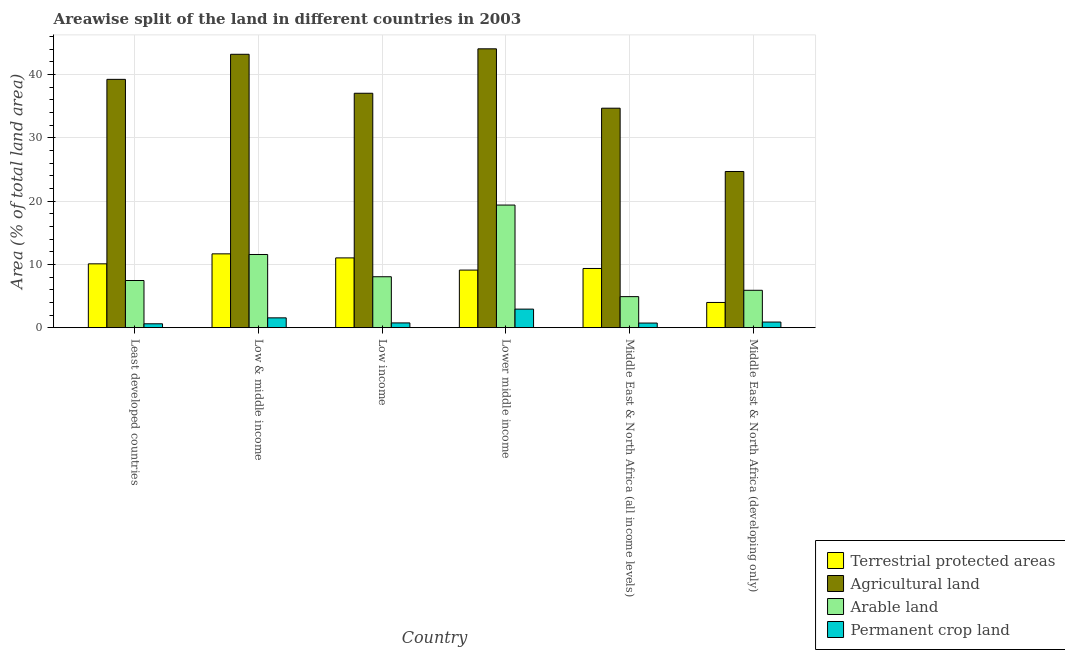How many bars are there on the 4th tick from the left?
Ensure brevity in your answer.  4. How many bars are there on the 1st tick from the right?
Make the answer very short. 4. What is the label of the 5th group of bars from the left?
Keep it short and to the point. Middle East & North Africa (all income levels). What is the percentage of area under agricultural land in Low income?
Provide a short and direct response. 37.05. Across all countries, what is the maximum percentage of land under terrestrial protection?
Offer a very short reply. 11.67. Across all countries, what is the minimum percentage of area under permanent crop land?
Ensure brevity in your answer.  0.61. In which country was the percentage of area under arable land maximum?
Your answer should be very brief. Lower middle income. In which country was the percentage of land under terrestrial protection minimum?
Your response must be concise. Middle East & North Africa (developing only). What is the total percentage of area under agricultural land in the graph?
Offer a very short reply. 222.98. What is the difference between the percentage of area under permanent crop land in Low & middle income and that in Lower middle income?
Offer a very short reply. -1.38. What is the difference between the percentage of area under arable land in Low income and the percentage of area under permanent crop land in Least developed countries?
Provide a succinct answer. 7.44. What is the average percentage of area under permanent crop land per country?
Your answer should be very brief. 1.24. What is the difference between the percentage of area under permanent crop land and percentage of land under terrestrial protection in Low & middle income?
Your response must be concise. -10.12. In how many countries, is the percentage of area under arable land greater than 14 %?
Provide a succinct answer. 1. What is the ratio of the percentage of area under arable land in Lower middle income to that in Middle East & North Africa (all income levels)?
Offer a terse response. 3.95. Is the percentage of area under arable land in Low income less than that in Lower middle income?
Your response must be concise. Yes. Is the difference between the percentage of area under arable land in Least developed countries and Lower middle income greater than the difference between the percentage of area under agricultural land in Least developed countries and Lower middle income?
Provide a short and direct response. No. What is the difference between the highest and the second highest percentage of land under terrestrial protection?
Your response must be concise. 0.64. What is the difference between the highest and the lowest percentage of area under permanent crop land?
Provide a succinct answer. 2.32. What does the 2nd bar from the left in Lower middle income represents?
Your answer should be compact. Agricultural land. What does the 4th bar from the right in Low income represents?
Your answer should be compact. Terrestrial protected areas. Are all the bars in the graph horizontal?
Your response must be concise. No. What is the difference between two consecutive major ticks on the Y-axis?
Ensure brevity in your answer.  10. How many legend labels are there?
Keep it short and to the point. 4. What is the title of the graph?
Keep it short and to the point. Areawise split of the land in different countries in 2003. What is the label or title of the X-axis?
Make the answer very short. Country. What is the label or title of the Y-axis?
Your response must be concise. Area (% of total land area). What is the Area (% of total land area) in Terrestrial protected areas in Least developed countries?
Keep it short and to the point. 10.09. What is the Area (% of total land area) of Agricultural land in Least developed countries?
Offer a very short reply. 39.25. What is the Area (% of total land area) of Arable land in Least developed countries?
Give a very brief answer. 7.45. What is the Area (% of total land area) of Permanent crop land in Least developed countries?
Make the answer very short. 0.61. What is the Area (% of total land area) of Terrestrial protected areas in Low & middle income?
Ensure brevity in your answer.  11.67. What is the Area (% of total land area) of Agricultural land in Low & middle income?
Keep it short and to the point. 43.21. What is the Area (% of total land area) of Arable land in Low & middle income?
Provide a short and direct response. 11.57. What is the Area (% of total land area) in Permanent crop land in Low & middle income?
Your answer should be very brief. 1.55. What is the Area (% of total land area) in Terrestrial protected areas in Low income?
Your answer should be compact. 11.03. What is the Area (% of total land area) of Agricultural land in Low income?
Provide a succinct answer. 37.05. What is the Area (% of total land area) of Arable land in Low income?
Provide a short and direct response. 8.05. What is the Area (% of total land area) in Permanent crop land in Low income?
Offer a very short reply. 0.75. What is the Area (% of total land area) in Terrestrial protected areas in Lower middle income?
Give a very brief answer. 9.1. What is the Area (% of total land area) of Agricultural land in Lower middle income?
Provide a succinct answer. 44.08. What is the Area (% of total land area) in Arable land in Lower middle income?
Provide a succinct answer. 19.38. What is the Area (% of total land area) of Permanent crop land in Lower middle income?
Ensure brevity in your answer.  2.93. What is the Area (% of total land area) of Terrestrial protected areas in Middle East & North Africa (all income levels)?
Your answer should be very brief. 9.36. What is the Area (% of total land area) in Agricultural land in Middle East & North Africa (all income levels)?
Your answer should be compact. 34.69. What is the Area (% of total land area) of Arable land in Middle East & North Africa (all income levels)?
Offer a terse response. 4.9. What is the Area (% of total land area) in Permanent crop land in Middle East & North Africa (all income levels)?
Your response must be concise. 0.73. What is the Area (% of total land area) of Terrestrial protected areas in Middle East & North Africa (developing only)?
Offer a very short reply. 3.98. What is the Area (% of total land area) in Agricultural land in Middle East & North Africa (developing only)?
Keep it short and to the point. 24.69. What is the Area (% of total land area) of Arable land in Middle East & North Africa (developing only)?
Your answer should be compact. 5.91. What is the Area (% of total land area) in Permanent crop land in Middle East & North Africa (developing only)?
Make the answer very short. 0.89. Across all countries, what is the maximum Area (% of total land area) in Terrestrial protected areas?
Your answer should be very brief. 11.67. Across all countries, what is the maximum Area (% of total land area) in Agricultural land?
Your answer should be compact. 44.08. Across all countries, what is the maximum Area (% of total land area) of Arable land?
Give a very brief answer. 19.38. Across all countries, what is the maximum Area (% of total land area) in Permanent crop land?
Give a very brief answer. 2.93. Across all countries, what is the minimum Area (% of total land area) of Terrestrial protected areas?
Your response must be concise. 3.98. Across all countries, what is the minimum Area (% of total land area) of Agricultural land?
Offer a terse response. 24.69. Across all countries, what is the minimum Area (% of total land area) of Arable land?
Your response must be concise. 4.9. Across all countries, what is the minimum Area (% of total land area) of Permanent crop land?
Give a very brief answer. 0.61. What is the total Area (% of total land area) in Terrestrial protected areas in the graph?
Your answer should be compact. 55.23. What is the total Area (% of total land area) in Agricultural land in the graph?
Your answer should be very brief. 222.98. What is the total Area (% of total land area) in Arable land in the graph?
Keep it short and to the point. 57.26. What is the total Area (% of total land area) of Permanent crop land in the graph?
Offer a very short reply. 7.46. What is the difference between the Area (% of total land area) of Terrestrial protected areas in Least developed countries and that in Low & middle income?
Ensure brevity in your answer.  -1.58. What is the difference between the Area (% of total land area) in Agricultural land in Least developed countries and that in Low & middle income?
Make the answer very short. -3.96. What is the difference between the Area (% of total land area) of Arable land in Least developed countries and that in Low & middle income?
Make the answer very short. -4.11. What is the difference between the Area (% of total land area) in Permanent crop land in Least developed countries and that in Low & middle income?
Provide a short and direct response. -0.94. What is the difference between the Area (% of total land area) of Terrestrial protected areas in Least developed countries and that in Low income?
Offer a terse response. -0.94. What is the difference between the Area (% of total land area) in Agricultural land in Least developed countries and that in Low income?
Your response must be concise. 2.2. What is the difference between the Area (% of total land area) in Arable land in Least developed countries and that in Low income?
Give a very brief answer. -0.6. What is the difference between the Area (% of total land area) of Permanent crop land in Least developed countries and that in Low income?
Your response must be concise. -0.14. What is the difference between the Area (% of total land area) in Terrestrial protected areas in Least developed countries and that in Lower middle income?
Your answer should be very brief. 0.99. What is the difference between the Area (% of total land area) of Agricultural land in Least developed countries and that in Lower middle income?
Offer a very short reply. -4.83. What is the difference between the Area (% of total land area) of Arable land in Least developed countries and that in Lower middle income?
Your answer should be compact. -11.93. What is the difference between the Area (% of total land area) of Permanent crop land in Least developed countries and that in Lower middle income?
Make the answer very short. -2.32. What is the difference between the Area (% of total land area) in Terrestrial protected areas in Least developed countries and that in Middle East & North Africa (all income levels)?
Offer a terse response. 0.73. What is the difference between the Area (% of total land area) of Agricultural land in Least developed countries and that in Middle East & North Africa (all income levels)?
Make the answer very short. 4.56. What is the difference between the Area (% of total land area) of Arable land in Least developed countries and that in Middle East & North Africa (all income levels)?
Offer a terse response. 2.55. What is the difference between the Area (% of total land area) in Permanent crop land in Least developed countries and that in Middle East & North Africa (all income levels)?
Give a very brief answer. -0.12. What is the difference between the Area (% of total land area) of Terrestrial protected areas in Least developed countries and that in Middle East & North Africa (developing only)?
Offer a very short reply. 6.11. What is the difference between the Area (% of total land area) of Agricultural land in Least developed countries and that in Middle East & North Africa (developing only)?
Keep it short and to the point. 14.57. What is the difference between the Area (% of total land area) in Arable land in Least developed countries and that in Middle East & North Africa (developing only)?
Your answer should be compact. 1.55. What is the difference between the Area (% of total land area) of Permanent crop land in Least developed countries and that in Middle East & North Africa (developing only)?
Offer a terse response. -0.27. What is the difference between the Area (% of total land area) of Terrestrial protected areas in Low & middle income and that in Low income?
Keep it short and to the point. 0.64. What is the difference between the Area (% of total land area) of Agricultural land in Low & middle income and that in Low income?
Your answer should be very brief. 6.16. What is the difference between the Area (% of total land area) in Arable land in Low & middle income and that in Low income?
Offer a terse response. 3.52. What is the difference between the Area (% of total land area) of Permanent crop land in Low & middle income and that in Low income?
Your answer should be very brief. 0.8. What is the difference between the Area (% of total land area) of Terrestrial protected areas in Low & middle income and that in Lower middle income?
Your response must be concise. 2.57. What is the difference between the Area (% of total land area) in Agricultural land in Low & middle income and that in Lower middle income?
Your answer should be compact. -0.87. What is the difference between the Area (% of total land area) of Arable land in Low & middle income and that in Lower middle income?
Offer a terse response. -7.82. What is the difference between the Area (% of total land area) in Permanent crop land in Low & middle income and that in Lower middle income?
Offer a terse response. -1.38. What is the difference between the Area (% of total land area) in Terrestrial protected areas in Low & middle income and that in Middle East & North Africa (all income levels)?
Ensure brevity in your answer.  2.31. What is the difference between the Area (% of total land area) in Agricultural land in Low & middle income and that in Middle East & North Africa (all income levels)?
Provide a short and direct response. 8.52. What is the difference between the Area (% of total land area) of Arable land in Low & middle income and that in Middle East & North Africa (all income levels)?
Offer a terse response. 6.66. What is the difference between the Area (% of total land area) of Permanent crop land in Low & middle income and that in Middle East & North Africa (all income levels)?
Provide a succinct answer. 0.82. What is the difference between the Area (% of total land area) of Terrestrial protected areas in Low & middle income and that in Middle East & North Africa (developing only)?
Your answer should be compact. 7.69. What is the difference between the Area (% of total land area) of Agricultural land in Low & middle income and that in Middle East & North Africa (developing only)?
Keep it short and to the point. 18.53. What is the difference between the Area (% of total land area) in Arable land in Low & middle income and that in Middle East & North Africa (developing only)?
Give a very brief answer. 5.66. What is the difference between the Area (% of total land area) in Permanent crop land in Low & middle income and that in Middle East & North Africa (developing only)?
Your response must be concise. 0.66. What is the difference between the Area (% of total land area) of Terrestrial protected areas in Low income and that in Lower middle income?
Offer a terse response. 1.93. What is the difference between the Area (% of total land area) of Agricultural land in Low income and that in Lower middle income?
Offer a very short reply. -7.03. What is the difference between the Area (% of total land area) of Arable land in Low income and that in Lower middle income?
Offer a very short reply. -11.33. What is the difference between the Area (% of total land area) in Permanent crop land in Low income and that in Lower middle income?
Ensure brevity in your answer.  -2.18. What is the difference between the Area (% of total land area) of Terrestrial protected areas in Low income and that in Middle East & North Africa (all income levels)?
Keep it short and to the point. 1.67. What is the difference between the Area (% of total land area) of Agricultural land in Low income and that in Middle East & North Africa (all income levels)?
Your answer should be compact. 2.36. What is the difference between the Area (% of total land area) of Arable land in Low income and that in Middle East & North Africa (all income levels)?
Provide a succinct answer. 3.14. What is the difference between the Area (% of total land area) of Permanent crop land in Low income and that in Middle East & North Africa (all income levels)?
Give a very brief answer. 0.02. What is the difference between the Area (% of total land area) of Terrestrial protected areas in Low income and that in Middle East & North Africa (developing only)?
Provide a succinct answer. 7.04. What is the difference between the Area (% of total land area) in Agricultural land in Low income and that in Middle East & North Africa (developing only)?
Keep it short and to the point. 12.37. What is the difference between the Area (% of total land area) in Arable land in Low income and that in Middle East & North Africa (developing only)?
Ensure brevity in your answer.  2.14. What is the difference between the Area (% of total land area) of Permanent crop land in Low income and that in Middle East & North Africa (developing only)?
Your answer should be compact. -0.14. What is the difference between the Area (% of total land area) in Terrestrial protected areas in Lower middle income and that in Middle East & North Africa (all income levels)?
Provide a succinct answer. -0.25. What is the difference between the Area (% of total land area) in Agricultural land in Lower middle income and that in Middle East & North Africa (all income levels)?
Your answer should be very brief. 9.39. What is the difference between the Area (% of total land area) in Arable land in Lower middle income and that in Middle East & North Africa (all income levels)?
Ensure brevity in your answer.  14.48. What is the difference between the Area (% of total land area) in Permanent crop land in Lower middle income and that in Middle East & North Africa (all income levels)?
Your answer should be compact. 2.2. What is the difference between the Area (% of total land area) of Terrestrial protected areas in Lower middle income and that in Middle East & North Africa (developing only)?
Make the answer very short. 5.12. What is the difference between the Area (% of total land area) in Agricultural land in Lower middle income and that in Middle East & North Africa (developing only)?
Offer a terse response. 19.39. What is the difference between the Area (% of total land area) of Arable land in Lower middle income and that in Middle East & North Africa (developing only)?
Ensure brevity in your answer.  13.47. What is the difference between the Area (% of total land area) in Permanent crop land in Lower middle income and that in Middle East & North Africa (developing only)?
Offer a very short reply. 2.05. What is the difference between the Area (% of total land area) of Terrestrial protected areas in Middle East & North Africa (all income levels) and that in Middle East & North Africa (developing only)?
Make the answer very short. 5.37. What is the difference between the Area (% of total land area) of Agricultural land in Middle East & North Africa (all income levels) and that in Middle East & North Africa (developing only)?
Your response must be concise. 10.01. What is the difference between the Area (% of total land area) of Arable land in Middle East & North Africa (all income levels) and that in Middle East & North Africa (developing only)?
Offer a very short reply. -1. What is the difference between the Area (% of total land area) in Permanent crop land in Middle East & North Africa (all income levels) and that in Middle East & North Africa (developing only)?
Your answer should be very brief. -0.16. What is the difference between the Area (% of total land area) of Terrestrial protected areas in Least developed countries and the Area (% of total land area) of Agricultural land in Low & middle income?
Offer a terse response. -33.12. What is the difference between the Area (% of total land area) in Terrestrial protected areas in Least developed countries and the Area (% of total land area) in Arable land in Low & middle income?
Your answer should be very brief. -1.48. What is the difference between the Area (% of total land area) in Terrestrial protected areas in Least developed countries and the Area (% of total land area) in Permanent crop land in Low & middle income?
Provide a succinct answer. 8.54. What is the difference between the Area (% of total land area) in Agricultural land in Least developed countries and the Area (% of total land area) in Arable land in Low & middle income?
Offer a very short reply. 27.69. What is the difference between the Area (% of total land area) of Agricultural land in Least developed countries and the Area (% of total land area) of Permanent crop land in Low & middle income?
Offer a terse response. 37.7. What is the difference between the Area (% of total land area) in Arable land in Least developed countries and the Area (% of total land area) in Permanent crop land in Low & middle income?
Your answer should be compact. 5.9. What is the difference between the Area (% of total land area) of Terrestrial protected areas in Least developed countries and the Area (% of total land area) of Agricultural land in Low income?
Offer a terse response. -26.96. What is the difference between the Area (% of total land area) in Terrestrial protected areas in Least developed countries and the Area (% of total land area) in Arable land in Low income?
Offer a very short reply. 2.04. What is the difference between the Area (% of total land area) of Terrestrial protected areas in Least developed countries and the Area (% of total land area) of Permanent crop land in Low income?
Your answer should be compact. 9.34. What is the difference between the Area (% of total land area) in Agricultural land in Least developed countries and the Area (% of total land area) in Arable land in Low income?
Make the answer very short. 31.2. What is the difference between the Area (% of total land area) in Agricultural land in Least developed countries and the Area (% of total land area) in Permanent crop land in Low income?
Your response must be concise. 38.5. What is the difference between the Area (% of total land area) of Arable land in Least developed countries and the Area (% of total land area) of Permanent crop land in Low income?
Ensure brevity in your answer.  6.7. What is the difference between the Area (% of total land area) in Terrestrial protected areas in Least developed countries and the Area (% of total land area) in Agricultural land in Lower middle income?
Ensure brevity in your answer.  -33.99. What is the difference between the Area (% of total land area) in Terrestrial protected areas in Least developed countries and the Area (% of total land area) in Arable land in Lower middle income?
Make the answer very short. -9.29. What is the difference between the Area (% of total land area) of Terrestrial protected areas in Least developed countries and the Area (% of total land area) of Permanent crop land in Lower middle income?
Keep it short and to the point. 7.16. What is the difference between the Area (% of total land area) of Agricultural land in Least developed countries and the Area (% of total land area) of Arable land in Lower middle income?
Your response must be concise. 19.87. What is the difference between the Area (% of total land area) of Agricultural land in Least developed countries and the Area (% of total land area) of Permanent crop land in Lower middle income?
Offer a very short reply. 36.32. What is the difference between the Area (% of total land area) in Arable land in Least developed countries and the Area (% of total land area) in Permanent crop land in Lower middle income?
Make the answer very short. 4.52. What is the difference between the Area (% of total land area) of Terrestrial protected areas in Least developed countries and the Area (% of total land area) of Agricultural land in Middle East & North Africa (all income levels)?
Provide a succinct answer. -24.6. What is the difference between the Area (% of total land area) of Terrestrial protected areas in Least developed countries and the Area (% of total land area) of Arable land in Middle East & North Africa (all income levels)?
Offer a terse response. 5.18. What is the difference between the Area (% of total land area) in Terrestrial protected areas in Least developed countries and the Area (% of total land area) in Permanent crop land in Middle East & North Africa (all income levels)?
Offer a terse response. 9.36. What is the difference between the Area (% of total land area) of Agricultural land in Least developed countries and the Area (% of total land area) of Arable land in Middle East & North Africa (all income levels)?
Give a very brief answer. 34.35. What is the difference between the Area (% of total land area) of Agricultural land in Least developed countries and the Area (% of total land area) of Permanent crop land in Middle East & North Africa (all income levels)?
Your answer should be compact. 38.53. What is the difference between the Area (% of total land area) of Arable land in Least developed countries and the Area (% of total land area) of Permanent crop land in Middle East & North Africa (all income levels)?
Make the answer very short. 6.73. What is the difference between the Area (% of total land area) of Terrestrial protected areas in Least developed countries and the Area (% of total land area) of Agricultural land in Middle East & North Africa (developing only)?
Ensure brevity in your answer.  -14.6. What is the difference between the Area (% of total land area) of Terrestrial protected areas in Least developed countries and the Area (% of total land area) of Arable land in Middle East & North Africa (developing only)?
Provide a succinct answer. 4.18. What is the difference between the Area (% of total land area) of Terrestrial protected areas in Least developed countries and the Area (% of total land area) of Permanent crop land in Middle East & North Africa (developing only)?
Your answer should be very brief. 9.2. What is the difference between the Area (% of total land area) in Agricultural land in Least developed countries and the Area (% of total land area) in Arable land in Middle East & North Africa (developing only)?
Ensure brevity in your answer.  33.35. What is the difference between the Area (% of total land area) in Agricultural land in Least developed countries and the Area (% of total land area) in Permanent crop land in Middle East & North Africa (developing only)?
Offer a very short reply. 38.37. What is the difference between the Area (% of total land area) of Arable land in Least developed countries and the Area (% of total land area) of Permanent crop land in Middle East & North Africa (developing only)?
Your answer should be very brief. 6.57. What is the difference between the Area (% of total land area) in Terrestrial protected areas in Low & middle income and the Area (% of total land area) in Agricultural land in Low income?
Provide a short and direct response. -25.39. What is the difference between the Area (% of total land area) in Terrestrial protected areas in Low & middle income and the Area (% of total land area) in Arable land in Low income?
Your answer should be very brief. 3.62. What is the difference between the Area (% of total land area) of Terrestrial protected areas in Low & middle income and the Area (% of total land area) of Permanent crop land in Low income?
Provide a short and direct response. 10.92. What is the difference between the Area (% of total land area) of Agricultural land in Low & middle income and the Area (% of total land area) of Arable land in Low income?
Ensure brevity in your answer.  35.16. What is the difference between the Area (% of total land area) of Agricultural land in Low & middle income and the Area (% of total land area) of Permanent crop land in Low income?
Your answer should be compact. 42.46. What is the difference between the Area (% of total land area) of Arable land in Low & middle income and the Area (% of total land area) of Permanent crop land in Low income?
Make the answer very short. 10.82. What is the difference between the Area (% of total land area) in Terrestrial protected areas in Low & middle income and the Area (% of total land area) in Agricultural land in Lower middle income?
Give a very brief answer. -32.41. What is the difference between the Area (% of total land area) in Terrestrial protected areas in Low & middle income and the Area (% of total land area) in Arable land in Lower middle income?
Your response must be concise. -7.71. What is the difference between the Area (% of total land area) of Terrestrial protected areas in Low & middle income and the Area (% of total land area) of Permanent crop land in Lower middle income?
Keep it short and to the point. 8.74. What is the difference between the Area (% of total land area) in Agricultural land in Low & middle income and the Area (% of total land area) in Arable land in Lower middle income?
Offer a terse response. 23.83. What is the difference between the Area (% of total land area) in Agricultural land in Low & middle income and the Area (% of total land area) in Permanent crop land in Lower middle income?
Keep it short and to the point. 40.28. What is the difference between the Area (% of total land area) in Arable land in Low & middle income and the Area (% of total land area) in Permanent crop land in Lower middle income?
Provide a short and direct response. 8.63. What is the difference between the Area (% of total land area) in Terrestrial protected areas in Low & middle income and the Area (% of total land area) in Agricultural land in Middle East & North Africa (all income levels)?
Provide a succinct answer. -23.03. What is the difference between the Area (% of total land area) of Terrestrial protected areas in Low & middle income and the Area (% of total land area) of Arable land in Middle East & North Africa (all income levels)?
Keep it short and to the point. 6.76. What is the difference between the Area (% of total land area) in Terrestrial protected areas in Low & middle income and the Area (% of total land area) in Permanent crop land in Middle East & North Africa (all income levels)?
Provide a short and direct response. 10.94. What is the difference between the Area (% of total land area) of Agricultural land in Low & middle income and the Area (% of total land area) of Arable land in Middle East & North Africa (all income levels)?
Give a very brief answer. 38.31. What is the difference between the Area (% of total land area) of Agricultural land in Low & middle income and the Area (% of total land area) of Permanent crop land in Middle East & North Africa (all income levels)?
Ensure brevity in your answer.  42.49. What is the difference between the Area (% of total land area) of Arable land in Low & middle income and the Area (% of total land area) of Permanent crop land in Middle East & North Africa (all income levels)?
Offer a very short reply. 10.84. What is the difference between the Area (% of total land area) of Terrestrial protected areas in Low & middle income and the Area (% of total land area) of Agricultural land in Middle East & North Africa (developing only)?
Offer a terse response. -13.02. What is the difference between the Area (% of total land area) in Terrestrial protected areas in Low & middle income and the Area (% of total land area) in Arable land in Middle East & North Africa (developing only)?
Offer a terse response. 5.76. What is the difference between the Area (% of total land area) in Terrestrial protected areas in Low & middle income and the Area (% of total land area) in Permanent crop land in Middle East & North Africa (developing only)?
Provide a succinct answer. 10.78. What is the difference between the Area (% of total land area) of Agricultural land in Low & middle income and the Area (% of total land area) of Arable land in Middle East & North Africa (developing only)?
Your response must be concise. 37.31. What is the difference between the Area (% of total land area) of Agricultural land in Low & middle income and the Area (% of total land area) of Permanent crop land in Middle East & North Africa (developing only)?
Your answer should be very brief. 42.33. What is the difference between the Area (% of total land area) of Arable land in Low & middle income and the Area (% of total land area) of Permanent crop land in Middle East & North Africa (developing only)?
Offer a very short reply. 10.68. What is the difference between the Area (% of total land area) in Terrestrial protected areas in Low income and the Area (% of total land area) in Agricultural land in Lower middle income?
Offer a terse response. -33.05. What is the difference between the Area (% of total land area) in Terrestrial protected areas in Low income and the Area (% of total land area) in Arable land in Lower middle income?
Make the answer very short. -8.35. What is the difference between the Area (% of total land area) in Terrestrial protected areas in Low income and the Area (% of total land area) in Permanent crop land in Lower middle income?
Your answer should be compact. 8.1. What is the difference between the Area (% of total land area) of Agricultural land in Low income and the Area (% of total land area) of Arable land in Lower middle income?
Give a very brief answer. 17.67. What is the difference between the Area (% of total land area) of Agricultural land in Low income and the Area (% of total land area) of Permanent crop land in Lower middle income?
Make the answer very short. 34.12. What is the difference between the Area (% of total land area) of Arable land in Low income and the Area (% of total land area) of Permanent crop land in Lower middle income?
Keep it short and to the point. 5.12. What is the difference between the Area (% of total land area) of Terrestrial protected areas in Low income and the Area (% of total land area) of Agricultural land in Middle East & North Africa (all income levels)?
Ensure brevity in your answer.  -23.67. What is the difference between the Area (% of total land area) of Terrestrial protected areas in Low income and the Area (% of total land area) of Arable land in Middle East & North Africa (all income levels)?
Your answer should be very brief. 6.12. What is the difference between the Area (% of total land area) in Terrestrial protected areas in Low income and the Area (% of total land area) in Permanent crop land in Middle East & North Africa (all income levels)?
Ensure brevity in your answer.  10.3. What is the difference between the Area (% of total land area) in Agricultural land in Low income and the Area (% of total land area) in Arable land in Middle East & North Africa (all income levels)?
Ensure brevity in your answer.  32.15. What is the difference between the Area (% of total land area) in Agricultural land in Low income and the Area (% of total land area) in Permanent crop land in Middle East & North Africa (all income levels)?
Offer a terse response. 36.33. What is the difference between the Area (% of total land area) in Arable land in Low income and the Area (% of total land area) in Permanent crop land in Middle East & North Africa (all income levels)?
Make the answer very short. 7.32. What is the difference between the Area (% of total land area) in Terrestrial protected areas in Low income and the Area (% of total land area) in Agricultural land in Middle East & North Africa (developing only)?
Your response must be concise. -13.66. What is the difference between the Area (% of total land area) of Terrestrial protected areas in Low income and the Area (% of total land area) of Arable land in Middle East & North Africa (developing only)?
Keep it short and to the point. 5.12. What is the difference between the Area (% of total land area) of Terrestrial protected areas in Low income and the Area (% of total land area) of Permanent crop land in Middle East & North Africa (developing only)?
Give a very brief answer. 10.14. What is the difference between the Area (% of total land area) of Agricultural land in Low income and the Area (% of total land area) of Arable land in Middle East & North Africa (developing only)?
Provide a succinct answer. 31.15. What is the difference between the Area (% of total land area) of Agricultural land in Low income and the Area (% of total land area) of Permanent crop land in Middle East & North Africa (developing only)?
Keep it short and to the point. 36.17. What is the difference between the Area (% of total land area) in Arable land in Low income and the Area (% of total land area) in Permanent crop land in Middle East & North Africa (developing only)?
Provide a succinct answer. 7.16. What is the difference between the Area (% of total land area) of Terrestrial protected areas in Lower middle income and the Area (% of total land area) of Agricultural land in Middle East & North Africa (all income levels)?
Offer a very short reply. -25.59. What is the difference between the Area (% of total land area) in Terrestrial protected areas in Lower middle income and the Area (% of total land area) in Arable land in Middle East & North Africa (all income levels)?
Your answer should be compact. 4.2. What is the difference between the Area (% of total land area) in Terrestrial protected areas in Lower middle income and the Area (% of total land area) in Permanent crop land in Middle East & North Africa (all income levels)?
Your answer should be compact. 8.37. What is the difference between the Area (% of total land area) in Agricultural land in Lower middle income and the Area (% of total land area) in Arable land in Middle East & North Africa (all income levels)?
Make the answer very short. 39.17. What is the difference between the Area (% of total land area) of Agricultural land in Lower middle income and the Area (% of total land area) of Permanent crop land in Middle East & North Africa (all income levels)?
Provide a succinct answer. 43.35. What is the difference between the Area (% of total land area) in Arable land in Lower middle income and the Area (% of total land area) in Permanent crop land in Middle East & North Africa (all income levels)?
Provide a succinct answer. 18.65. What is the difference between the Area (% of total land area) in Terrestrial protected areas in Lower middle income and the Area (% of total land area) in Agricultural land in Middle East & North Africa (developing only)?
Offer a terse response. -15.58. What is the difference between the Area (% of total land area) of Terrestrial protected areas in Lower middle income and the Area (% of total land area) of Arable land in Middle East & North Africa (developing only)?
Keep it short and to the point. 3.2. What is the difference between the Area (% of total land area) in Terrestrial protected areas in Lower middle income and the Area (% of total land area) in Permanent crop land in Middle East & North Africa (developing only)?
Your answer should be very brief. 8.22. What is the difference between the Area (% of total land area) in Agricultural land in Lower middle income and the Area (% of total land area) in Arable land in Middle East & North Africa (developing only)?
Make the answer very short. 38.17. What is the difference between the Area (% of total land area) in Agricultural land in Lower middle income and the Area (% of total land area) in Permanent crop land in Middle East & North Africa (developing only)?
Make the answer very short. 43.19. What is the difference between the Area (% of total land area) in Arable land in Lower middle income and the Area (% of total land area) in Permanent crop land in Middle East & North Africa (developing only)?
Your response must be concise. 18.5. What is the difference between the Area (% of total land area) in Terrestrial protected areas in Middle East & North Africa (all income levels) and the Area (% of total land area) in Agricultural land in Middle East & North Africa (developing only)?
Your answer should be compact. -15.33. What is the difference between the Area (% of total land area) in Terrestrial protected areas in Middle East & North Africa (all income levels) and the Area (% of total land area) in Arable land in Middle East & North Africa (developing only)?
Provide a short and direct response. 3.45. What is the difference between the Area (% of total land area) of Terrestrial protected areas in Middle East & North Africa (all income levels) and the Area (% of total land area) of Permanent crop land in Middle East & North Africa (developing only)?
Offer a terse response. 8.47. What is the difference between the Area (% of total land area) in Agricultural land in Middle East & North Africa (all income levels) and the Area (% of total land area) in Arable land in Middle East & North Africa (developing only)?
Provide a succinct answer. 28.79. What is the difference between the Area (% of total land area) in Agricultural land in Middle East & North Africa (all income levels) and the Area (% of total land area) in Permanent crop land in Middle East & North Africa (developing only)?
Offer a terse response. 33.81. What is the difference between the Area (% of total land area) of Arable land in Middle East & North Africa (all income levels) and the Area (% of total land area) of Permanent crop land in Middle East & North Africa (developing only)?
Ensure brevity in your answer.  4.02. What is the average Area (% of total land area) of Terrestrial protected areas per country?
Provide a short and direct response. 9.2. What is the average Area (% of total land area) of Agricultural land per country?
Offer a terse response. 37.16. What is the average Area (% of total land area) in Arable land per country?
Give a very brief answer. 9.54. What is the average Area (% of total land area) in Permanent crop land per country?
Offer a terse response. 1.24. What is the difference between the Area (% of total land area) of Terrestrial protected areas and Area (% of total land area) of Agricultural land in Least developed countries?
Make the answer very short. -29.16. What is the difference between the Area (% of total land area) in Terrestrial protected areas and Area (% of total land area) in Arable land in Least developed countries?
Provide a succinct answer. 2.64. What is the difference between the Area (% of total land area) in Terrestrial protected areas and Area (% of total land area) in Permanent crop land in Least developed countries?
Your response must be concise. 9.48. What is the difference between the Area (% of total land area) of Agricultural land and Area (% of total land area) of Arable land in Least developed countries?
Give a very brief answer. 31.8. What is the difference between the Area (% of total land area) of Agricultural land and Area (% of total land area) of Permanent crop land in Least developed countries?
Your answer should be very brief. 38.64. What is the difference between the Area (% of total land area) in Arable land and Area (% of total land area) in Permanent crop land in Least developed countries?
Provide a short and direct response. 6.84. What is the difference between the Area (% of total land area) of Terrestrial protected areas and Area (% of total land area) of Agricultural land in Low & middle income?
Your answer should be compact. -31.54. What is the difference between the Area (% of total land area) in Terrestrial protected areas and Area (% of total land area) in Arable land in Low & middle income?
Give a very brief answer. 0.1. What is the difference between the Area (% of total land area) of Terrestrial protected areas and Area (% of total land area) of Permanent crop land in Low & middle income?
Your answer should be compact. 10.12. What is the difference between the Area (% of total land area) of Agricultural land and Area (% of total land area) of Arable land in Low & middle income?
Offer a terse response. 31.65. What is the difference between the Area (% of total land area) in Agricultural land and Area (% of total land area) in Permanent crop land in Low & middle income?
Make the answer very short. 41.66. What is the difference between the Area (% of total land area) of Arable land and Area (% of total land area) of Permanent crop land in Low & middle income?
Your answer should be compact. 10.02. What is the difference between the Area (% of total land area) in Terrestrial protected areas and Area (% of total land area) in Agricultural land in Low income?
Give a very brief answer. -26.03. What is the difference between the Area (% of total land area) of Terrestrial protected areas and Area (% of total land area) of Arable land in Low income?
Provide a succinct answer. 2.98. What is the difference between the Area (% of total land area) in Terrestrial protected areas and Area (% of total land area) in Permanent crop land in Low income?
Your answer should be very brief. 10.28. What is the difference between the Area (% of total land area) in Agricultural land and Area (% of total land area) in Arable land in Low income?
Your answer should be compact. 29. What is the difference between the Area (% of total land area) in Agricultural land and Area (% of total land area) in Permanent crop land in Low income?
Provide a short and direct response. 36.3. What is the difference between the Area (% of total land area) in Terrestrial protected areas and Area (% of total land area) in Agricultural land in Lower middle income?
Your response must be concise. -34.98. What is the difference between the Area (% of total land area) in Terrestrial protected areas and Area (% of total land area) in Arable land in Lower middle income?
Your answer should be compact. -10.28. What is the difference between the Area (% of total land area) in Terrestrial protected areas and Area (% of total land area) in Permanent crop land in Lower middle income?
Your answer should be compact. 6.17. What is the difference between the Area (% of total land area) of Agricultural land and Area (% of total land area) of Arable land in Lower middle income?
Keep it short and to the point. 24.7. What is the difference between the Area (% of total land area) in Agricultural land and Area (% of total land area) in Permanent crop land in Lower middle income?
Ensure brevity in your answer.  41.15. What is the difference between the Area (% of total land area) in Arable land and Area (% of total land area) in Permanent crop land in Lower middle income?
Your response must be concise. 16.45. What is the difference between the Area (% of total land area) of Terrestrial protected areas and Area (% of total land area) of Agricultural land in Middle East & North Africa (all income levels)?
Ensure brevity in your answer.  -25.34. What is the difference between the Area (% of total land area) of Terrestrial protected areas and Area (% of total land area) of Arable land in Middle East & North Africa (all income levels)?
Give a very brief answer. 4.45. What is the difference between the Area (% of total land area) of Terrestrial protected areas and Area (% of total land area) of Permanent crop land in Middle East & North Africa (all income levels)?
Offer a terse response. 8.63. What is the difference between the Area (% of total land area) in Agricultural land and Area (% of total land area) in Arable land in Middle East & North Africa (all income levels)?
Your answer should be compact. 29.79. What is the difference between the Area (% of total land area) in Agricultural land and Area (% of total land area) in Permanent crop land in Middle East & North Africa (all income levels)?
Your response must be concise. 33.97. What is the difference between the Area (% of total land area) of Arable land and Area (% of total land area) of Permanent crop land in Middle East & North Africa (all income levels)?
Offer a very short reply. 4.18. What is the difference between the Area (% of total land area) of Terrestrial protected areas and Area (% of total land area) of Agricultural land in Middle East & North Africa (developing only)?
Your answer should be compact. -20.7. What is the difference between the Area (% of total land area) of Terrestrial protected areas and Area (% of total land area) of Arable land in Middle East & North Africa (developing only)?
Make the answer very short. -1.92. What is the difference between the Area (% of total land area) in Terrestrial protected areas and Area (% of total land area) in Permanent crop land in Middle East & North Africa (developing only)?
Ensure brevity in your answer.  3.1. What is the difference between the Area (% of total land area) in Agricultural land and Area (% of total land area) in Arable land in Middle East & North Africa (developing only)?
Make the answer very short. 18.78. What is the difference between the Area (% of total land area) of Agricultural land and Area (% of total land area) of Permanent crop land in Middle East & North Africa (developing only)?
Provide a succinct answer. 23.8. What is the difference between the Area (% of total land area) in Arable land and Area (% of total land area) in Permanent crop land in Middle East & North Africa (developing only)?
Make the answer very short. 5.02. What is the ratio of the Area (% of total land area) of Terrestrial protected areas in Least developed countries to that in Low & middle income?
Provide a succinct answer. 0.86. What is the ratio of the Area (% of total land area) of Agricultural land in Least developed countries to that in Low & middle income?
Your answer should be very brief. 0.91. What is the ratio of the Area (% of total land area) of Arable land in Least developed countries to that in Low & middle income?
Provide a short and direct response. 0.64. What is the ratio of the Area (% of total land area) of Permanent crop land in Least developed countries to that in Low & middle income?
Provide a succinct answer. 0.39. What is the ratio of the Area (% of total land area) in Terrestrial protected areas in Least developed countries to that in Low income?
Your response must be concise. 0.91. What is the ratio of the Area (% of total land area) in Agricultural land in Least developed countries to that in Low income?
Give a very brief answer. 1.06. What is the ratio of the Area (% of total land area) in Arable land in Least developed countries to that in Low income?
Offer a very short reply. 0.93. What is the ratio of the Area (% of total land area) in Permanent crop land in Least developed countries to that in Low income?
Keep it short and to the point. 0.82. What is the ratio of the Area (% of total land area) of Terrestrial protected areas in Least developed countries to that in Lower middle income?
Provide a short and direct response. 1.11. What is the ratio of the Area (% of total land area) in Agricultural land in Least developed countries to that in Lower middle income?
Your answer should be very brief. 0.89. What is the ratio of the Area (% of total land area) of Arable land in Least developed countries to that in Lower middle income?
Offer a very short reply. 0.38. What is the ratio of the Area (% of total land area) in Permanent crop land in Least developed countries to that in Lower middle income?
Your response must be concise. 0.21. What is the ratio of the Area (% of total land area) in Terrestrial protected areas in Least developed countries to that in Middle East & North Africa (all income levels)?
Ensure brevity in your answer.  1.08. What is the ratio of the Area (% of total land area) in Agricultural land in Least developed countries to that in Middle East & North Africa (all income levels)?
Ensure brevity in your answer.  1.13. What is the ratio of the Area (% of total land area) of Arable land in Least developed countries to that in Middle East & North Africa (all income levels)?
Offer a terse response. 1.52. What is the ratio of the Area (% of total land area) of Permanent crop land in Least developed countries to that in Middle East & North Africa (all income levels)?
Offer a terse response. 0.84. What is the ratio of the Area (% of total land area) of Terrestrial protected areas in Least developed countries to that in Middle East & North Africa (developing only)?
Offer a very short reply. 2.53. What is the ratio of the Area (% of total land area) of Agricultural land in Least developed countries to that in Middle East & North Africa (developing only)?
Your answer should be compact. 1.59. What is the ratio of the Area (% of total land area) of Arable land in Least developed countries to that in Middle East & North Africa (developing only)?
Offer a very short reply. 1.26. What is the ratio of the Area (% of total land area) in Permanent crop land in Least developed countries to that in Middle East & North Africa (developing only)?
Your answer should be compact. 0.69. What is the ratio of the Area (% of total land area) of Terrestrial protected areas in Low & middle income to that in Low income?
Your answer should be very brief. 1.06. What is the ratio of the Area (% of total land area) of Agricultural land in Low & middle income to that in Low income?
Offer a terse response. 1.17. What is the ratio of the Area (% of total land area) of Arable land in Low & middle income to that in Low income?
Provide a succinct answer. 1.44. What is the ratio of the Area (% of total land area) in Permanent crop land in Low & middle income to that in Low income?
Give a very brief answer. 2.07. What is the ratio of the Area (% of total land area) in Terrestrial protected areas in Low & middle income to that in Lower middle income?
Provide a succinct answer. 1.28. What is the ratio of the Area (% of total land area) in Agricultural land in Low & middle income to that in Lower middle income?
Make the answer very short. 0.98. What is the ratio of the Area (% of total land area) of Arable land in Low & middle income to that in Lower middle income?
Provide a short and direct response. 0.6. What is the ratio of the Area (% of total land area) of Permanent crop land in Low & middle income to that in Lower middle income?
Make the answer very short. 0.53. What is the ratio of the Area (% of total land area) of Terrestrial protected areas in Low & middle income to that in Middle East & North Africa (all income levels)?
Give a very brief answer. 1.25. What is the ratio of the Area (% of total land area) in Agricultural land in Low & middle income to that in Middle East & North Africa (all income levels)?
Make the answer very short. 1.25. What is the ratio of the Area (% of total land area) of Arable land in Low & middle income to that in Middle East & North Africa (all income levels)?
Provide a succinct answer. 2.36. What is the ratio of the Area (% of total land area) of Permanent crop land in Low & middle income to that in Middle East & North Africa (all income levels)?
Provide a succinct answer. 2.13. What is the ratio of the Area (% of total land area) of Terrestrial protected areas in Low & middle income to that in Middle East & North Africa (developing only)?
Provide a short and direct response. 2.93. What is the ratio of the Area (% of total land area) of Agricultural land in Low & middle income to that in Middle East & North Africa (developing only)?
Provide a succinct answer. 1.75. What is the ratio of the Area (% of total land area) of Arable land in Low & middle income to that in Middle East & North Africa (developing only)?
Make the answer very short. 1.96. What is the ratio of the Area (% of total land area) in Permanent crop land in Low & middle income to that in Middle East & North Africa (developing only)?
Offer a very short reply. 1.75. What is the ratio of the Area (% of total land area) of Terrestrial protected areas in Low income to that in Lower middle income?
Offer a terse response. 1.21. What is the ratio of the Area (% of total land area) in Agricultural land in Low income to that in Lower middle income?
Offer a very short reply. 0.84. What is the ratio of the Area (% of total land area) of Arable land in Low income to that in Lower middle income?
Your response must be concise. 0.42. What is the ratio of the Area (% of total land area) in Permanent crop land in Low income to that in Lower middle income?
Give a very brief answer. 0.26. What is the ratio of the Area (% of total land area) of Terrestrial protected areas in Low income to that in Middle East & North Africa (all income levels)?
Offer a terse response. 1.18. What is the ratio of the Area (% of total land area) in Agricultural land in Low income to that in Middle East & North Africa (all income levels)?
Offer a very short reply. 1.07. What is the ratio of the Area (% of total land area) of Arable land in Low income to that in Middle East & North Africa (all income levels)?
Your response must be concise. 1.64. What is the ratio of the Area (% of total land area) of Permanent crop land in Low income to that in Middle East & North Africa (all income levels)?
Provide a short and direct response. 1.03. What is the ratio of the Area (% of total land area) of Terrestrial protected areas in Low income to that in Middle East & North Africa (developing only)?
Make the answer very short. 2.77. What is the ratio of the Area (% of total land area) of Agricultural land in Low income to that in Middle East & North Africa (developing only)?
Your answer should be very brief. 1.5. What is the ratio of the Area (% of total land area) of Arable land in Low income to that in Middle East & North Africa (developing only)?
Keep it short and to the point. 1.36. What is the ratio of the Area (% of total land area) of Permanent crop land in Low income to that in Middle East & North Africa (developing only)?
Ensure brevity in your answer.  0.85. What is the ratio of the Area (% of total land area) in Terrestrial protected areas in Lower middle income to that in Middle East & North Africa (all income levels)?
Make the answer very short. 0.97. What is the ratio of the Area (% of total land area) in Agricultural land in Lower middle income to that in Middle East & North Africa (all income levels)?
Your answer should be very brief. 1.27. What is the ratio of the Area (% of total land area) in Arable land in Lower middle income to that in Middle East & North Africa (all income levels)?
Your answer should be very brief. 3.95. What is the ratio of the Area (% of total land area) in Permanent crop land in Lower middle income to that in Middle East & North Africa (all income levels)?
Ensure brevity in your answer.  4.03. What is the ratio of the Area (% of total land area) of Terrestrial protected areas in Lower middle income to that in Middle East & North Africa (developing only)?
Ensure brevity in your answer.  2.29. What is the ratio of the Area (% of total land area) in Agricultural land in Lower middle income to that in Middle East & North Africa (developing only)?
Your response must be concise. 1.79. What is the ratio of the Area (% of total land area) of Arable land in Lower middle income to that in Middle East & North Africa (developing only)?
Keep it short and to the point. 3.28. What is the ratio of the Area (% of total land area) of Permanent crop land in Lower middle income to that in Middle East & North Africa (developing only)?
Your answer should be compact. 3.31. What is the ratio of the Area (% of total land area) of Terrestrial protected areas in Middle East & North Africa (all income levels) to that in Middle East & North Africa (developing only)?
Your response must be concise. 2.35. What is the ratio of the Area (% of total land area) of Agricultural land in Middle East & North Africa (all income levels) to that in Middle East & North Africa (developing only)?
Give a very brief answer. 1.41. What is the ratio of the Area (% of total land area) in Arable land in Middle East & North Africa (all income levels) to that in Middle East & North Africa (developing only)?
Make the answer very short. 0.83. What is the ratio of the Area (% of total land area) of Permanent crop land in Middle East & North Africa (all income levels) to that in Middle East & North Africa (developing only)?
Your response must be concise. 0.82. What is the difference between the highest and the second highest Area (% of total land area) in Terrestrial protected areas?
Provide a short and direct response. 0.64. What is the difference between the highest and the second highest Area (% of total land area) in Agricultural land?
Provide a short and direct response. 0.87. What is the difference between the highest and the second highest Area (% of total land area) of Arable land?
Provide a short and direct response. 7.82. What is the difference between the highest and the second highest Area (% of total land area) of Permanent crop land?
Offer a very short reply. 1.38. What is the difference between the highest and the lowest Area (% of total land area) in Terrestrial protected areas?
Your answer should be compact. 7.69. What is the difference between the highest and the lowest Area (% of total land area) in Agricultural land?
Offer a terse response. 19.39. What is the difference between the highest and the lowest Area (% of total land area) of Arable land?
Make the answer very short. 14.48. What is the difference between the highest and the lowest Area (% of total land area) of Permanent crop land?
Make the answer very short. 2.32. 